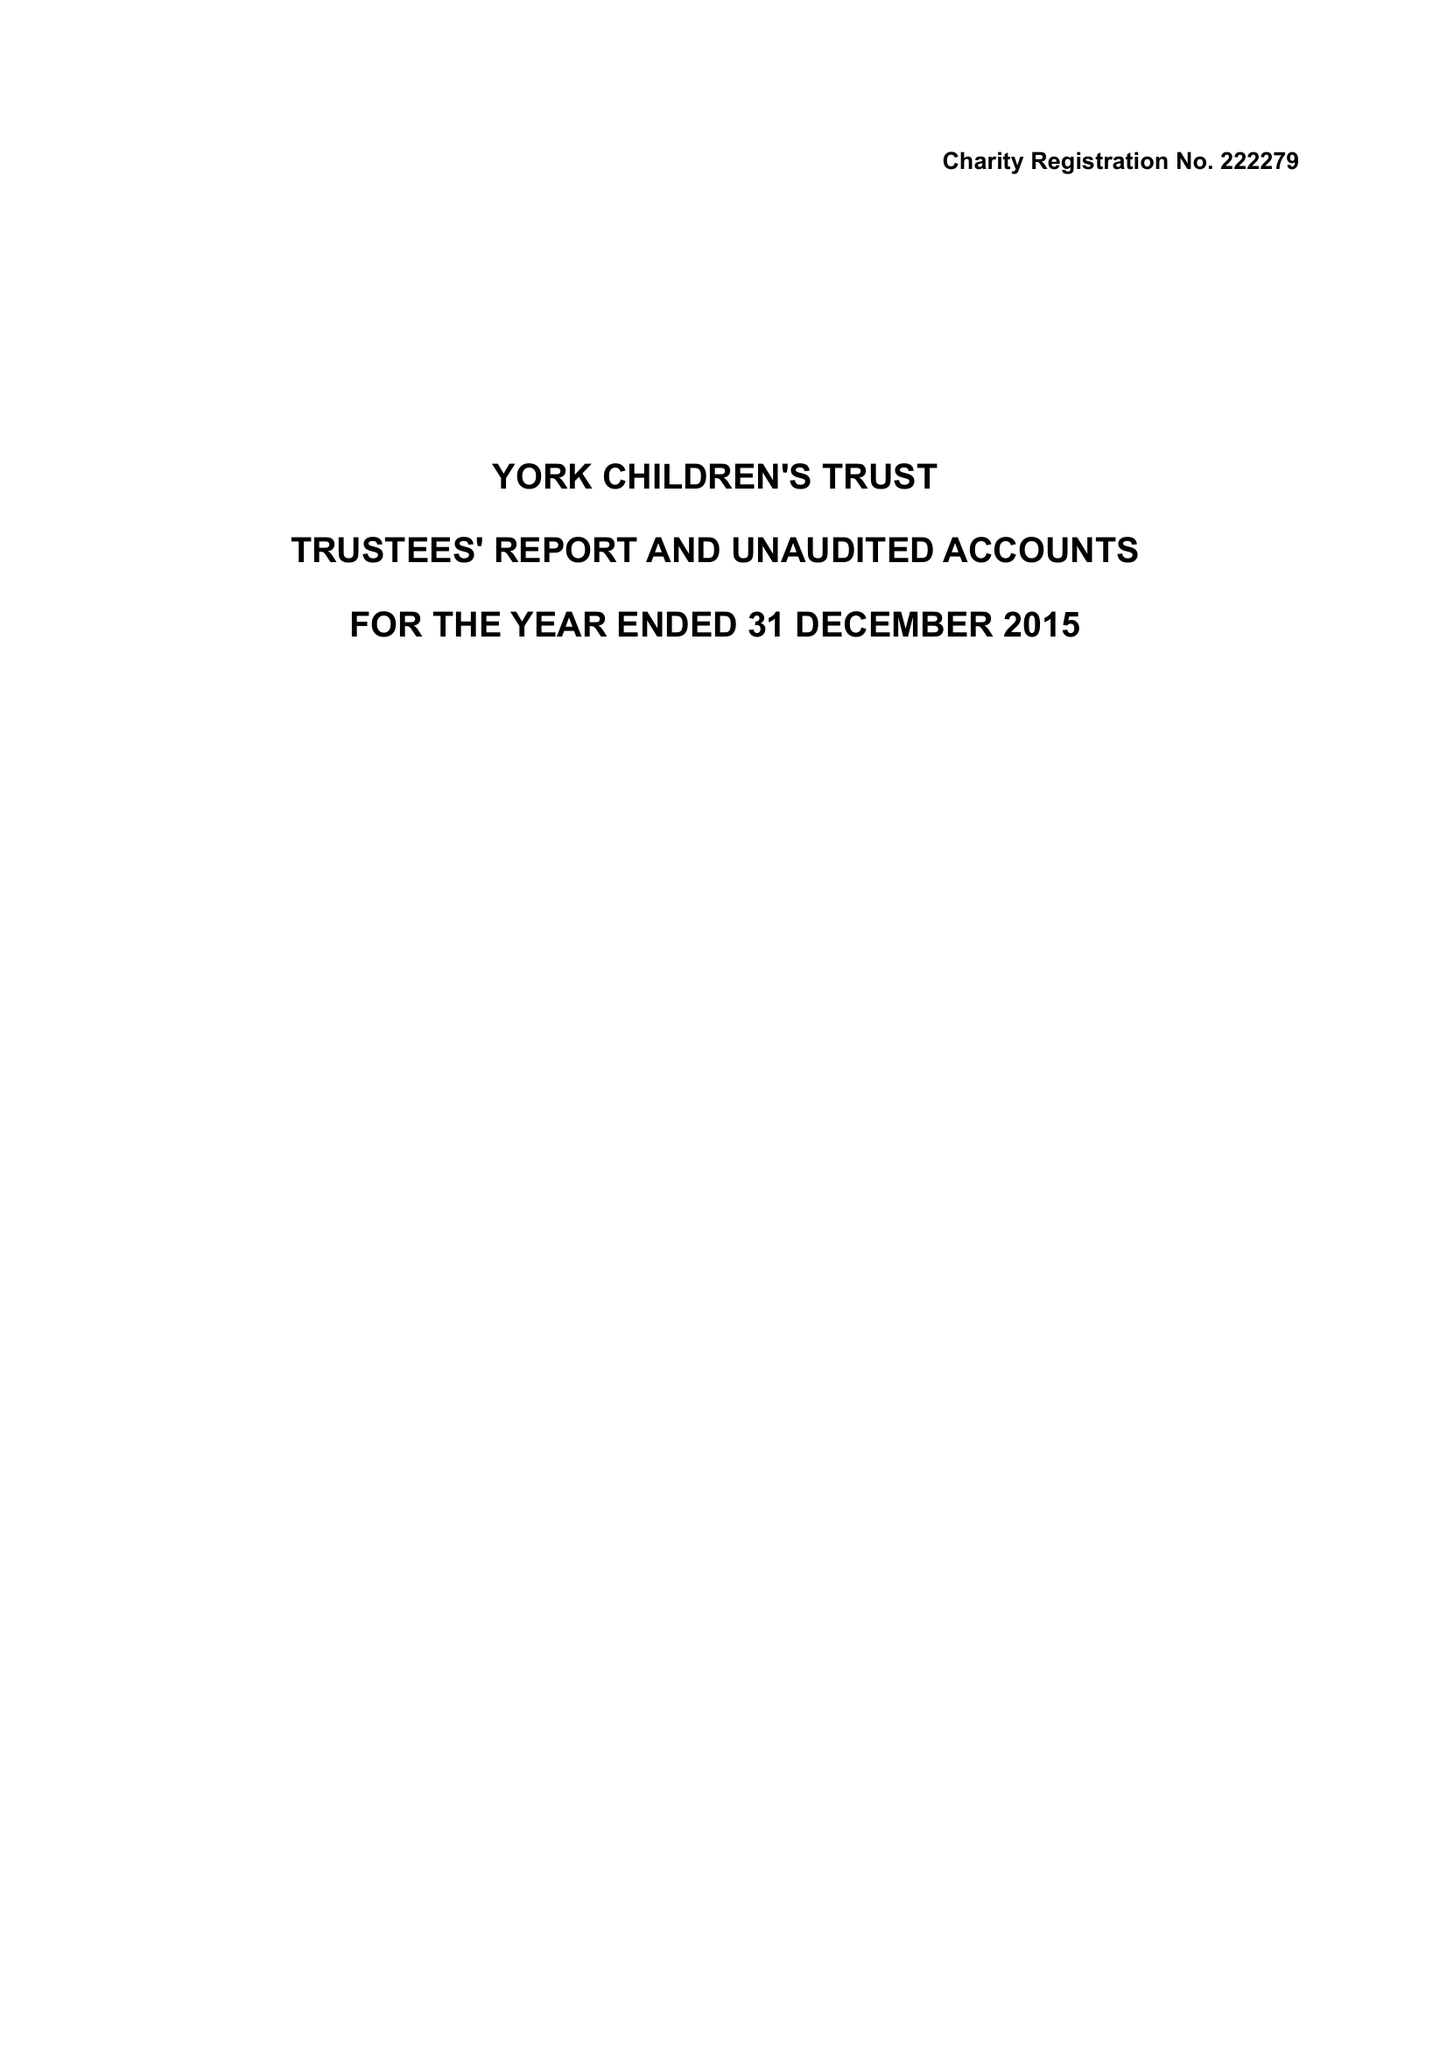What is the value for the address__street_line?
Answer the question using a single word or phrase. 29 WHINNEY LANE 